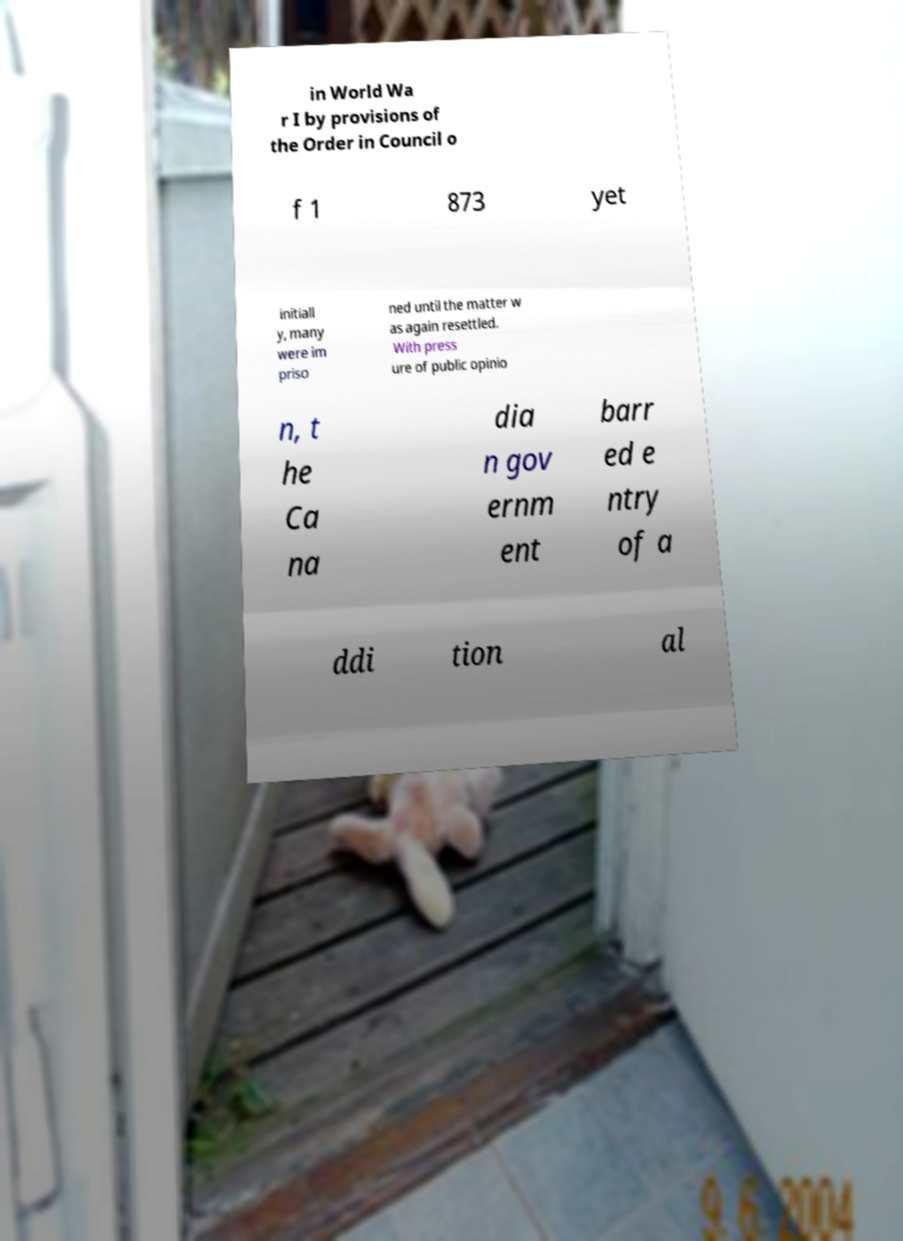Could you extract and type out the text from this image? in World Wa r I by provisions of the Order in Council o f 1 873 yet initiall y, many were im priso ned until the matter w as again resettled. With press ure of public opinio n, t he Ca na dia n gov ernm ent barr ed e ntry of a ddi tion al 